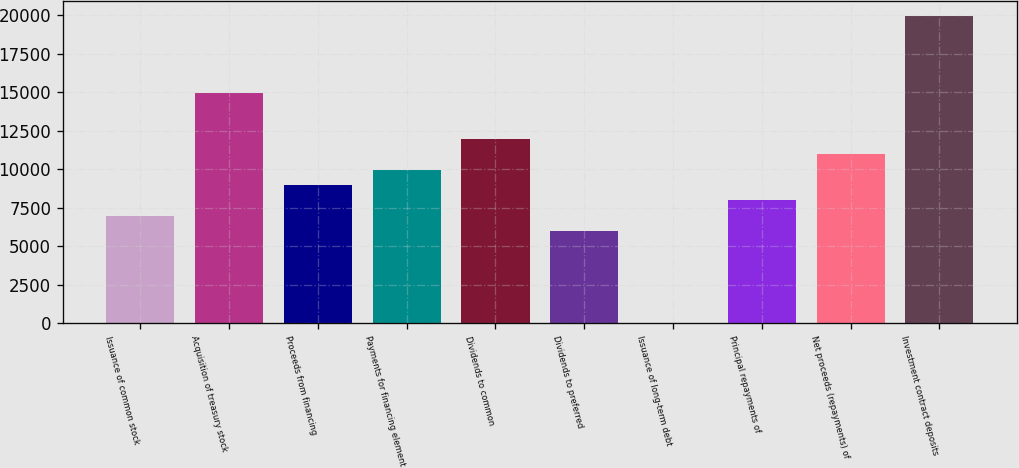Convert chart. <chart><loc_0><loc_0><loc_500><loc_500><bar_chart><fcel>Issuance of common stock<fcel>Acquisition of treasury stock<fcel>Proceeds from financing<fcel>Payments for financing element<fcel>Dividends to common<fcel>Dividends to preferred<fcel>Issuance of long-term debt<fcel>Principal repayments of<fcel>Net proceeds (repayments) of<fcel>Investment contract deposits<nl><fcel>6971.29<fcel>14938.2<fcel>8963.03<fcel>9958.9<fcel>11950.6<fcel>5975.42<fcel>0.2<fcel>7967.16<fcel>10954.8<fcel>19917.6<nl></chart> 